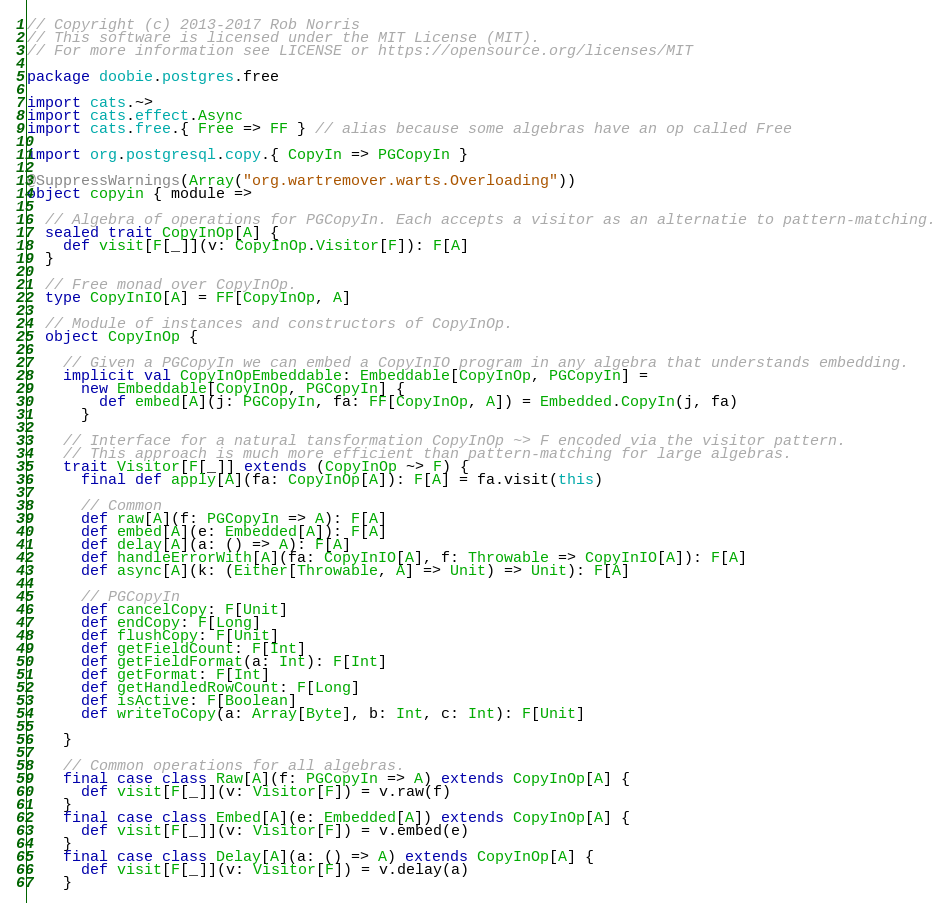<code> <loc_0><loc_0><loc_500><loc_500><_Scala_>// Copyright (c) 2013-2017 Rob Norris
// This software is licensed under the MIT License (MIT).
// For more information see LICENSE or https://opensource.org/licenses/MIT

package doobie.postgres.free

import cats.~>
import cats.effect.Async
import cats.free.{ Free => FF } // alias because some algebras have an op called Free

import org.postgresql.copy.{ CopyIn => PGCopyIn }

@SuppressWarnings(Array("org.wartremover.warts.Overloading"))
object copyin { module =>

  // Algebra of operations for PGCopyIn. Each accepts a visitor as an alternatie to pattern-matching.
  sealed trait CopyInOp[A] {
    def visit[F[_]](v: CopyInOp.Visitor[F]): F[A]
  }

  // Free monad over CopyInOp.
  type CopyInIO[A] = FF[CopyInOp, A]

  // Module of instances and constructors of CopyInOp.
  object CopyInOp {

    // Given a PGCopyIn we can embed a CopyInIO program in any algebra that understands embedding.
    implicit val CopyInOpEmbeddable: Embeddable[CopyInOp, PGCopyIn] =
      new Embeddable[CopyInOp, PGCopyIn] {
        def embed[A](j: PGCopyIn, fa: FF[CopyInOp, A]) = Embedded.CopyIn(j, fa)
      }

    // Interface for a natural tansformation CopyInOp ~> F encoded via the visitor pattern.
    // This approach is much more efficient than pattern-matching for large algebras.
    trait Visitor[F[_]] extends (CopyInOp ~> F) {
      final def apply[A](fa: CopyInOp[A]): F[A] = fa.visit(this)

      // Common
      def raw[A](f: PGCopyIn => A): F[A]
      def embed[A](e: Embedded[A]): F[A]
      def delay[A](a: () => A): F[A]
      def handleErrorWith[A](fa: CopyInIO[A], f: Throwable => CopyInIO[A]): F[A]
      def async[A](k: (Either[Throwable, A] => Unit) => Unit): F[A]

      // PGCopyIn
      def cancelCopy: F[Unit]
      def endCopy: F[Long]
      def flushCopy: F[Unit]
      def getFieldCount: F[Int]
      def getFieldFormat(a: Int): F[Int]
      def getFormat: F[Int]
      def getHandledRowCount: F[Long]
      def isActive: F[Boolean]
      def writeToCopy(a: Array[Byte], b: Int, c: Int): F[Unit]

    }

    // Common operations for all algebras.
    final case class Raw[A](f: PGCopyIn => A) extends CopyInOp[A] {
      def visit[F[_]](v: Visitor[F]) = v.raw(f)
    }
    final case class Embed[A](e: Embedded[A]) extends CopyInOp[A] {
      def visit[F[_]](v: Visitor[F]) = v.embed(e)
    }
    final case class Delay[A](a: () => A) extends CopyInOp[A] {
      def visit[F[_]](v: Visitor[F]) = v.delay(a)
    }</code> 